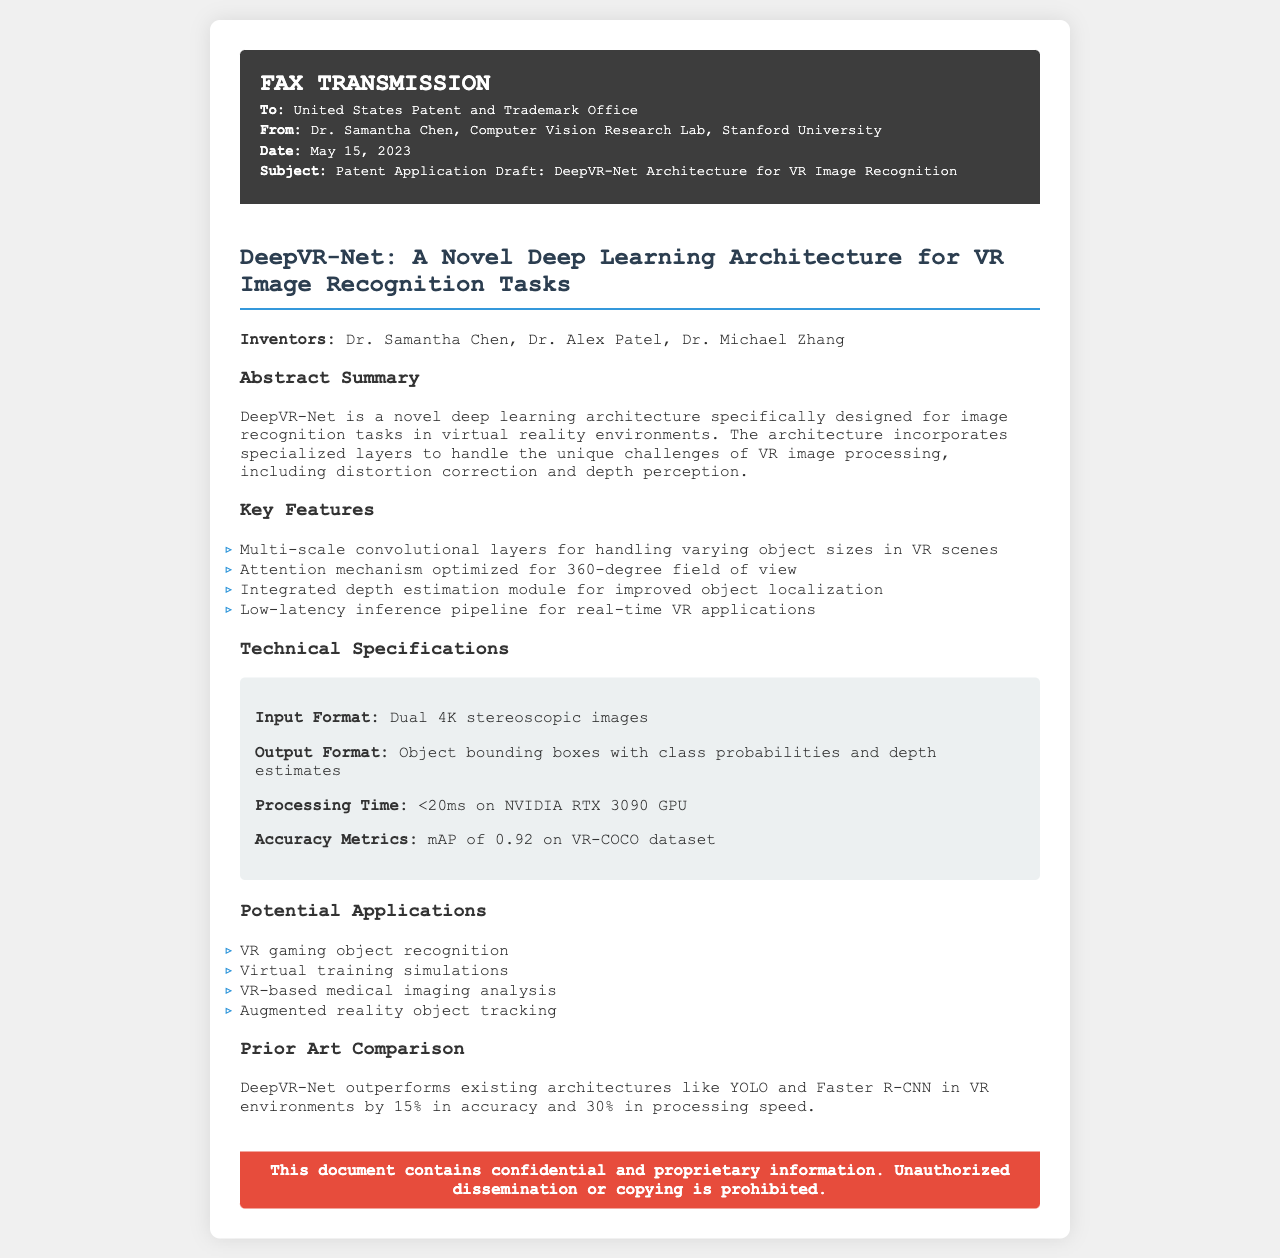What is the name of the novel architecture? The document explicitly states the name of the novel architecture as DeepVR-Net.
Answer: DeepVR-Net When was the patent application sent? The date of the fax transmission is clearly mentioned as May 15, 2023.
Answer: May 15, 2023 Who are the inventors of DeepVR-Net? The names of the inventors are listed in the document, identifying Dr. Samantha Chen, Dr. Alex Patel, and Dr. Michael Zhang.
Answer: Dr. Samantha Chen, Dr. Alex Patel, Dr. Michael Zhang What type of input format does DeepVR-Net use? The document specifies the input format required for the architecture is dual 4K stereoscopic images.
Answer: Dual 4K stereoscopic images What is the accuracy metric achieved by DeepVR-Net on the VR-COCO dataset? The document states that the accuracy metric reported is a mean Average Precision of 0.92.
Answer: mAP of 0.92 How much faster is DeepVR-Net compared to existing architectures in processing speed? The document claims DeepVR-Net is 30% faster than existing architectures like YOLO and Faster R-CNN.
Answer: 30% What is the potential application in virtual training simulations? The document lists virtual training simulations as one of the potential applications of DeepVR-Net.
Answer: Virtual training simulations What does the confidentiality notice indicate? The end section of the document indicates that the document contains confidential and proprietary information.
Answer: Confidential and proprietary information 